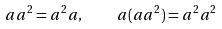<formula> <loc_0><loc_0><loc_500><loc_500>a a ^ { 2 } = a ^ { 2 } a , \quad a ( a a ^ { 2 } ) = a ^ { 2 } a ^ { 2 }</formula> 